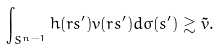Convert formula to latex. <formula><loc_0><loc_0><loc_500><loc_500>\int _ { S ^ { n - 1 } } h ( r s ^ { \prime } ) v ( r s ^ { \prime } ) d \sigma ( s ^ { \prime } ) \gtrsim \tilde { v } .</formula> 